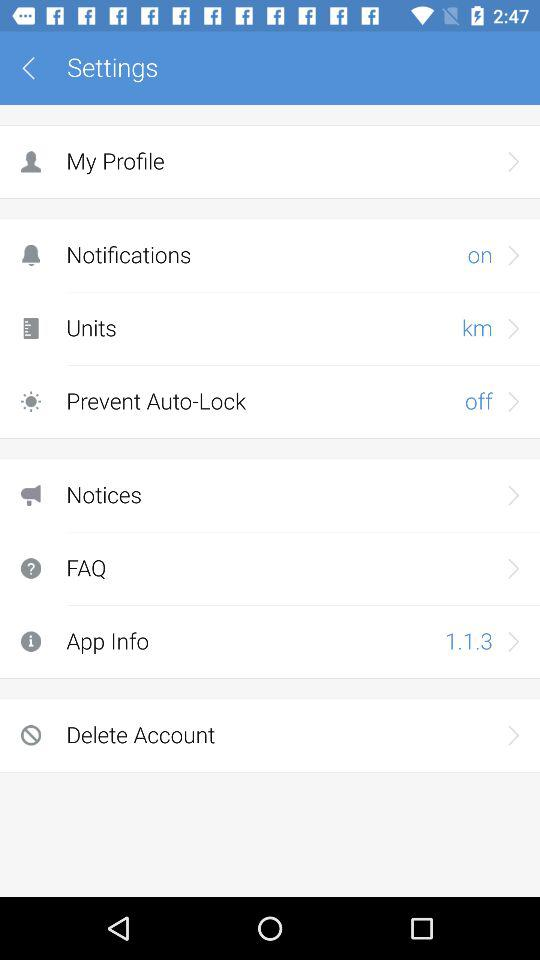What is the current status of "Prevent Auto-Lock"? The status is "off". 